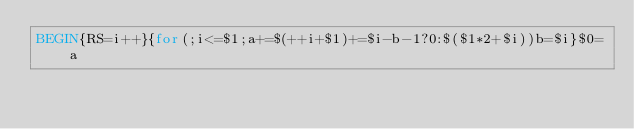Convert code to text. <code><loc_0><loc_0><loc_500><loc_500><_Awk_>BEGIN{RS=i++}{for(;i<=$1;a+=$(++i+$1)+=$i-b-1?0:$($1*2+$i))b=$i}$0=a</code> 